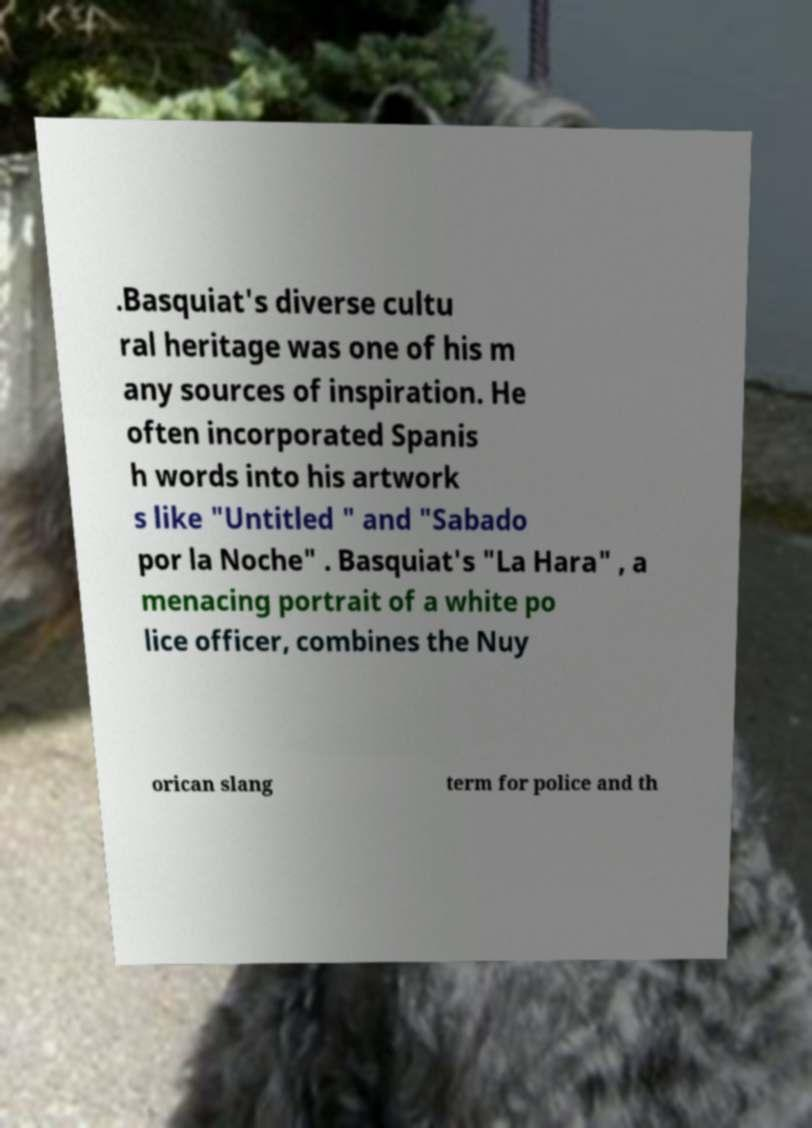I need the written content from this picture converted into text. Can you do that? .Basquiat's diverse cultu ral heritage was one of his m any sources of inspiration. He often incorporated Spanis h words into his artwork s like "Untitled " and "Sabado por la Noche" . Basquiat's "La Hara" , a menacing portrait of a white po lice officer, combines the Nuy orican slang term for police and th 